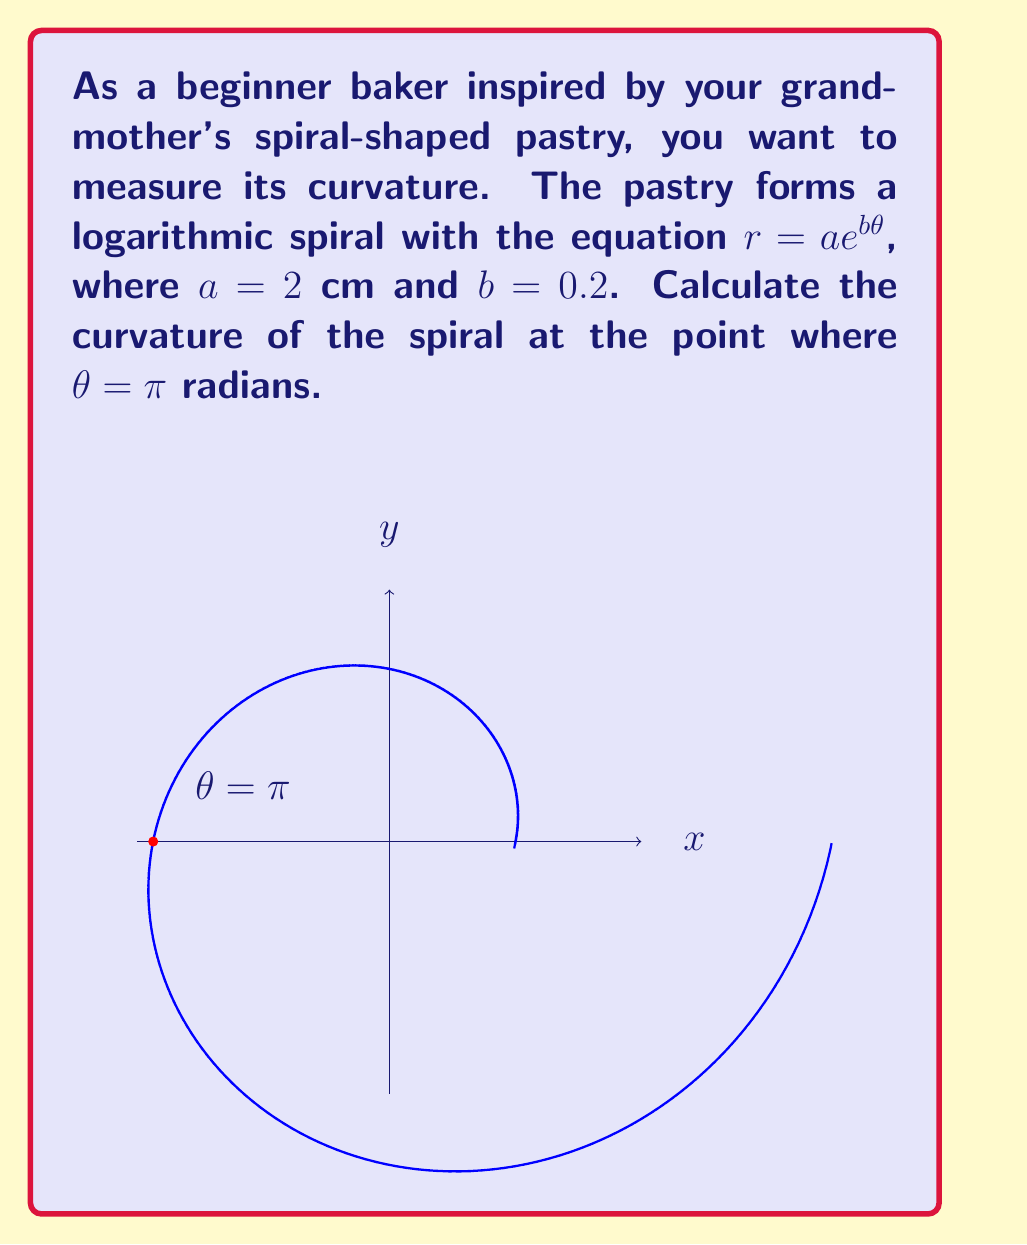Help me with this question. To find the curvature of a logarithmic spiral, we'll follow these steps:

1) The curvature $\kappa$ of a polar curve is given by:

   $$\kappa = \frac{|r^2 + 2(r')^2 - rr''|}{(r^2 + (r')^2)^{3/2}}$$

2) For a logarithmic spiral $r = ae^{b\theta}$, we need to calculate $r$, $r'$, and $r''$:
   
   $r = ae^{b\theta}$
   $r' = abe^{b\theta}$
   $r'' = ab^2e^{b\theta}$

3) Substitute $a = 2$, $b = 0.2$, and $\theta = \pi$:
   
   $r = 2e^{0.2\pi} \approx 3.38$
   $r' = 2 \cdot 0.2 \cdot e^{0.2\pi} \approx 0.68$
   $r'' = 2 \cdot 0.2^2 \cdot e^{0.2\pi} \approx 0.14$

4) Now, let's substitute these values into the curvature formula:

   $$\kappa = \frac{|(3.38)^2 + 2(0.68)^2 - 3.38 \cdot 0.14|}{((3.38)^2 + (0.68)^2)^{3/2}}$$

5) Simplify:

   $$\kappa = \frac{|11.42 + 0.92 - 0.47|}{(11.42 + 0.46)^{3/2}} = \frac{11.87}{(11.88)^{3/2}} \approx 0.29$$

Therefore, the curvature of the spiral at $\theta = \pi$ is approximately 0.29 cm^(-1).
Answer: $0.29$ cm$^{-1}$ 